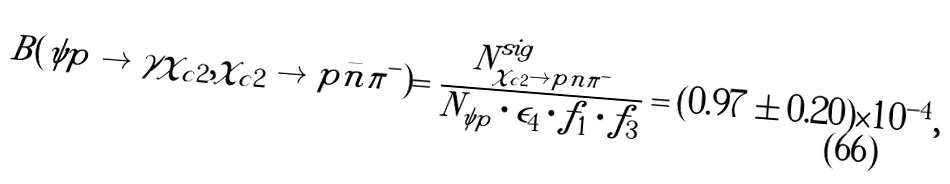Convert formula to latex. <formula><loc_0><loc_0><loc_500><loc_500>B ( \psi p \to \gamma \chi _ { c 2 } , \chi _ { c 2 } \to p \bar { n } \pi ^ { - } ) = \frac { N ^ { s i g } _ { \chi _ { c 2 } \to p \bar { n } \pi ^ { - } } } { N _ { \psi p } \cdot \epsilon _ { 4 } \cdot f _ { 1 } \cdot f _ { 3 } } = ( 0 . 9 7 \pm 0 . 2 0 ) \times 1 0 ^ { - 4 } ,</formula> 